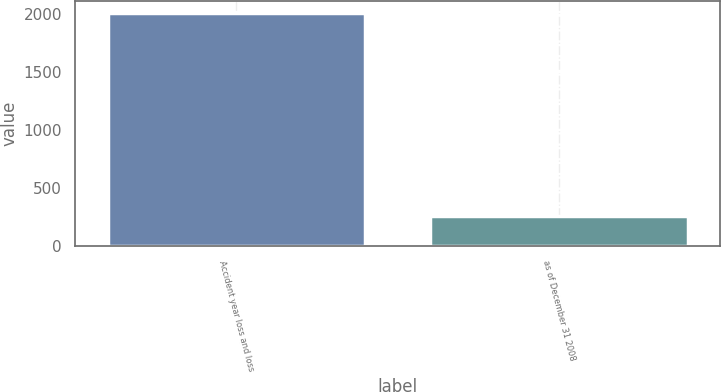<chart> <loc_0><loc_0><loc_500><loc_500><bar_chart><fcel>Accident year loss and loss<fcel>as of December 31 2008<nl><fcel>2007<fcel>260<nl></chart> 